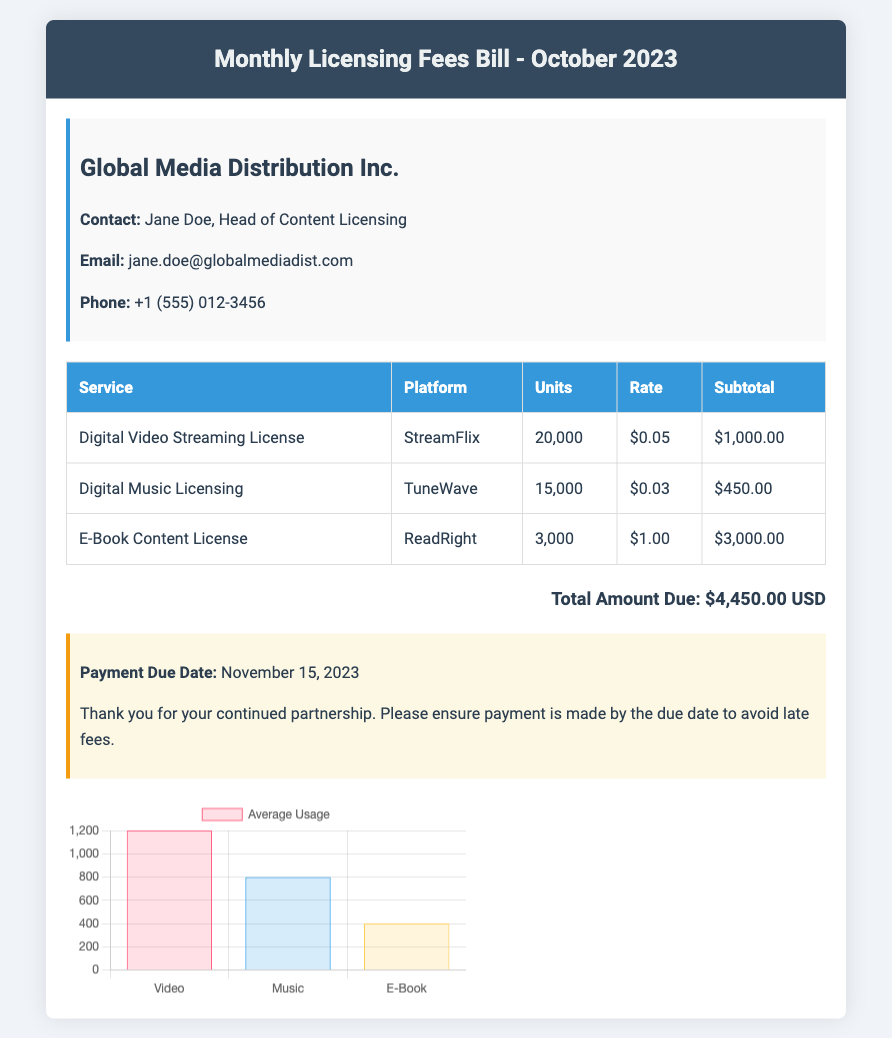What is the total amount due? The total amount due is listed at the bottom of the document, which is $4,450.00 USD.
Answer: $4,450.00 USD Who is the contact person for Global Media Distribution Inc.? The document states that the contact person is Jane Doe, Head of Content Licensing.
Answer: Jane Doe When is the payment due date? The payment due date is provided in the notes section, which shows November 15, 2023.
Answer: November 15, 2023 How many units of the Digital Music Licensing were licensed? The document lists that 15,000 units of Digital Music Licensing were licensed.
Answer: 15,000 What is the rate for the E-Book Content License? The rate for the E-Book Content License is specified in the table as $1.00.
Answer: $1.00 Which platform has the highest total for licensing fees? By comparing the subtotals of each service, the E-Book Content License on ReadRight has the highest subtotal of $3,000.00.
Answer: ReadRight How many total units of digital licenses were used? The total number of units is the sum of the units in the table, calculated as 20,000 + 15,000 + 3,000 = 38,000.
Answer: 38,000 What is the average usage for the Digital Video Streaming? The document presents the average usage for Digital Video Streaming as 1200 in the chart.
Answer: 1200 What is the subtotal for the Digital Video Streaming License? The subtotal for Digital Video Streaming License is shown in the table as $1,000.00.
Answer: $1,000.00 